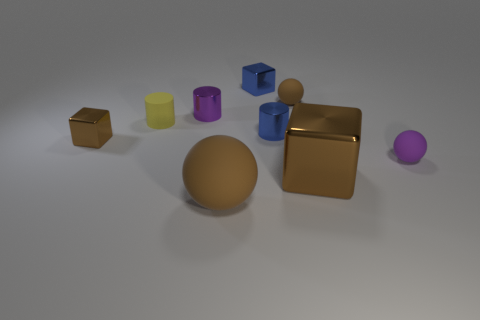Subtract all cubes. How many objects are left? 6 Add 3 tiny objects. How many tiny objects are left? 10 Add 6 large matte spheres. How many large matte spheres exist? 7 Subtract 0 green blocks. How many objects are left? 9 Subtract all metallic blocks. Subtract all small yellow rubber objects. How many objects are left? 5 